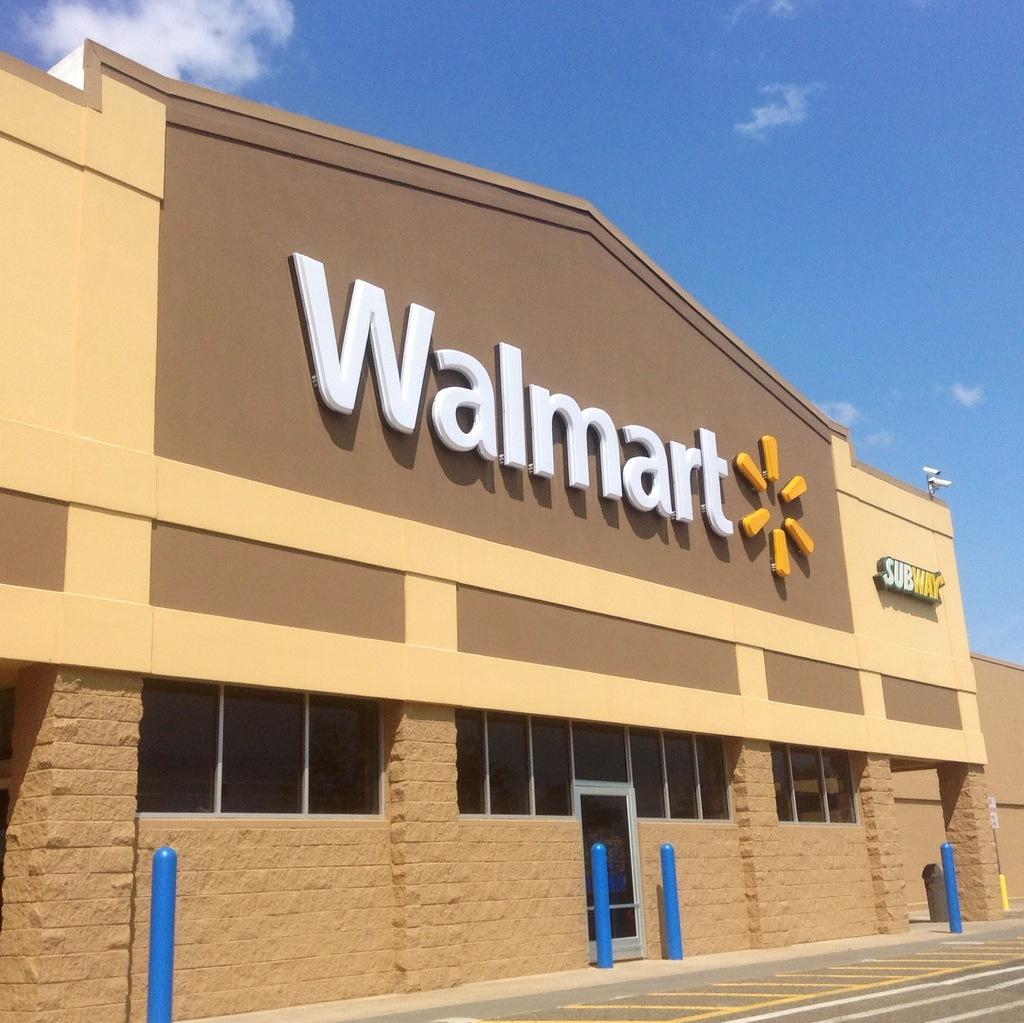In one or two sentences, can you explain what this image depicts? In this image I can see the building, few poles in blue color, glass windows and I can see few boards attached to the building. In the background the sky is in blue and white color. 